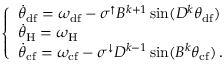Convert formula to latex. <formula><loc_0><loc_0><loc_500><loc_500>\begin{array} { r } { \left \{ \begin{array} { l l } { \ D o t { \theta } _ { d f } = \omega _ { d f } - \sigma ^ { \uparrow } B ^ { k + 1 } \sin ( D ^ { k } \theta _ { d f } ) } \\ { \ D o t { \theta } _ { H } = \omega _ { H } } \\ { \ D o t { \theta } _ { c f } = \omega _ { c f } - \sigma ^ { \downarrow } D ^ { k - 1 } \sin ( B ^ { k } \theta _ { c f } ) \, . } \end{array} } \end{array}</formula> 